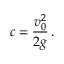Convert formula to latex. <formula><loc_0><loc_0><loc_500><loc_500>c = \frac { v _ { 0 } ^ { 2 } } { 2 g } \, .</formula> 